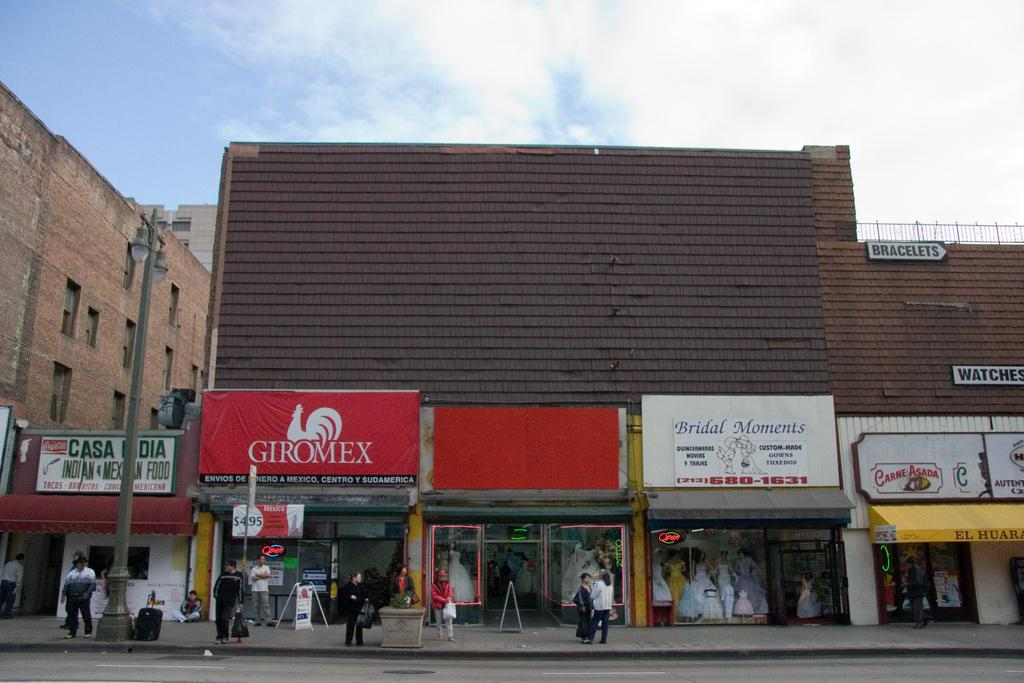<image>
Describe the image concisely. Giromex is the name shown on the billboard above this shop. 